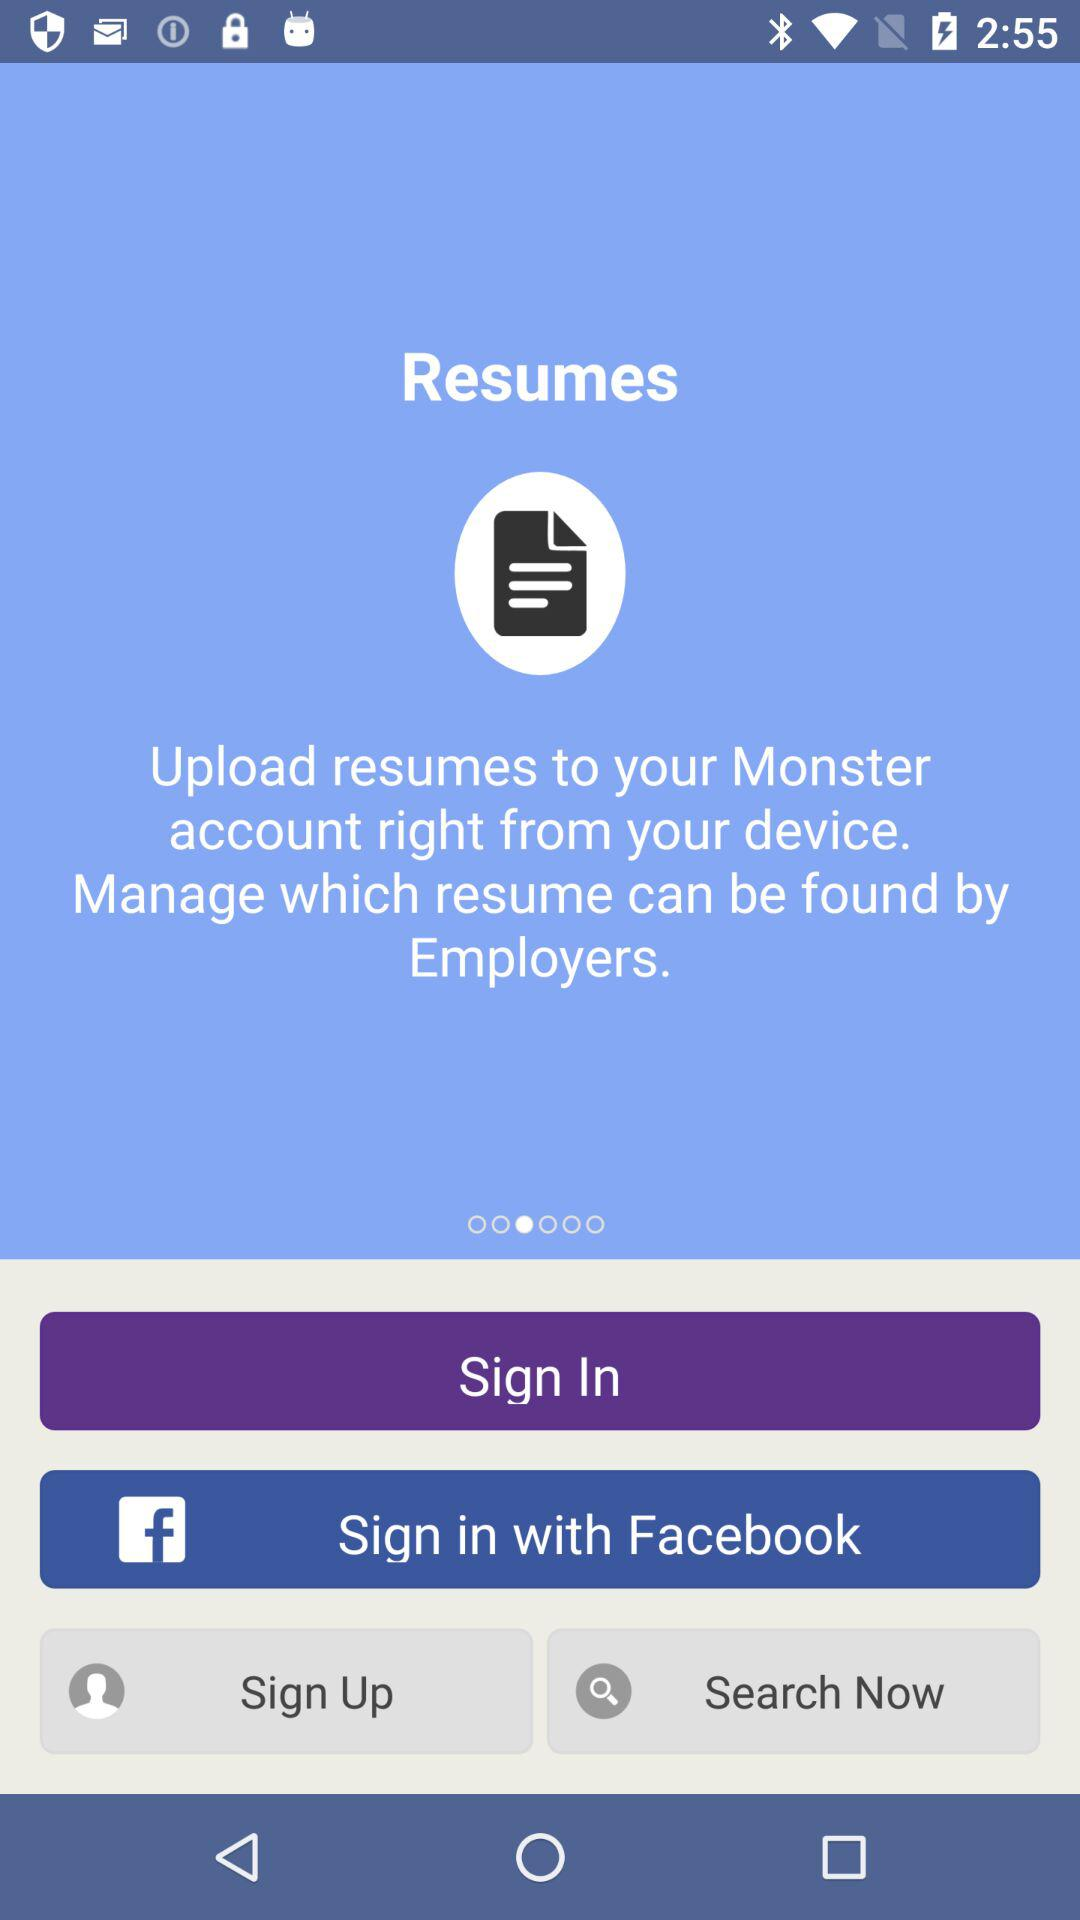Where can we upload resumes? You can upload resumes to your "Monster" account. 